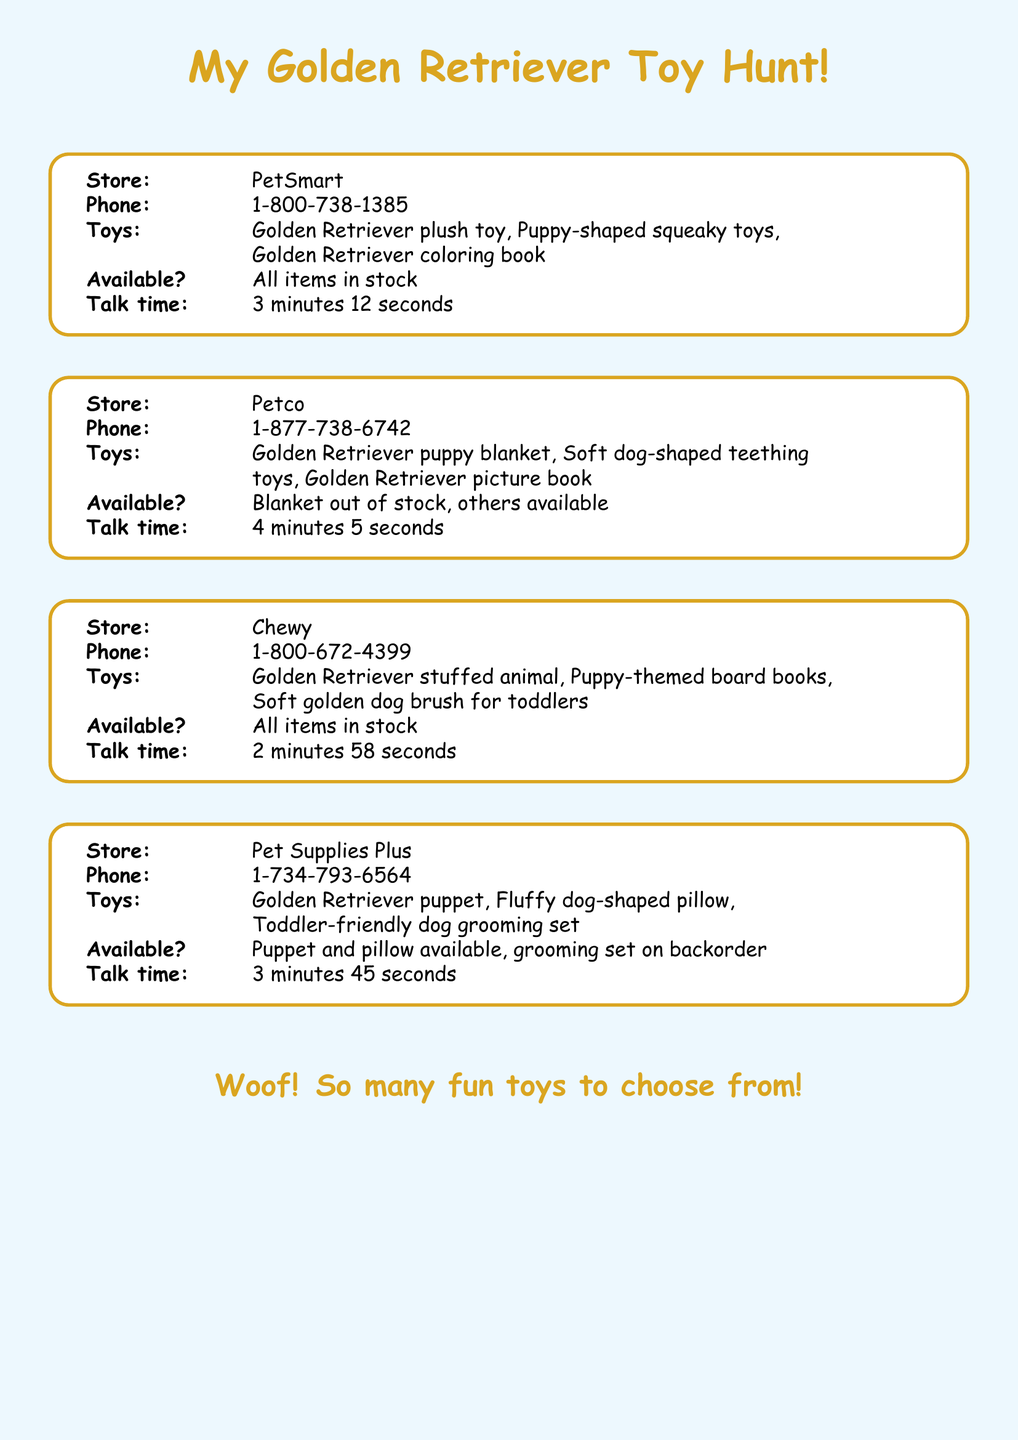What is the phone number for PetSmart? The phone number for PetSmart can be found in the contact details of the document.
Answer: 1-800-738-1385 Which toy is out of stock at Petco? The document specifies which toys are available or out of stock at Petco, highlighting the blanket.
Answer: Blanket How long was the call to Chewy? The duration of the call is recorded in the document for each store.
Answer: 2 minutes 58 seconds What types of toys are available at Pet Supplies Plus? The document lists the available toys at Pet Supplies Plus and includes the puppet and pillow.
Answer: Puppet and pillow How many toys are listed for PetSmart? The document details the number of specific toys available at PetSmart, which can be counted in the list.
Answer: Three 